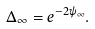Convert formula to latex. <formula><loc_0><loc_0><loc_500><loc_500>\Delta _ { \infty } = e ^ { - 2 \psi _ { \infty } } .</formula> 